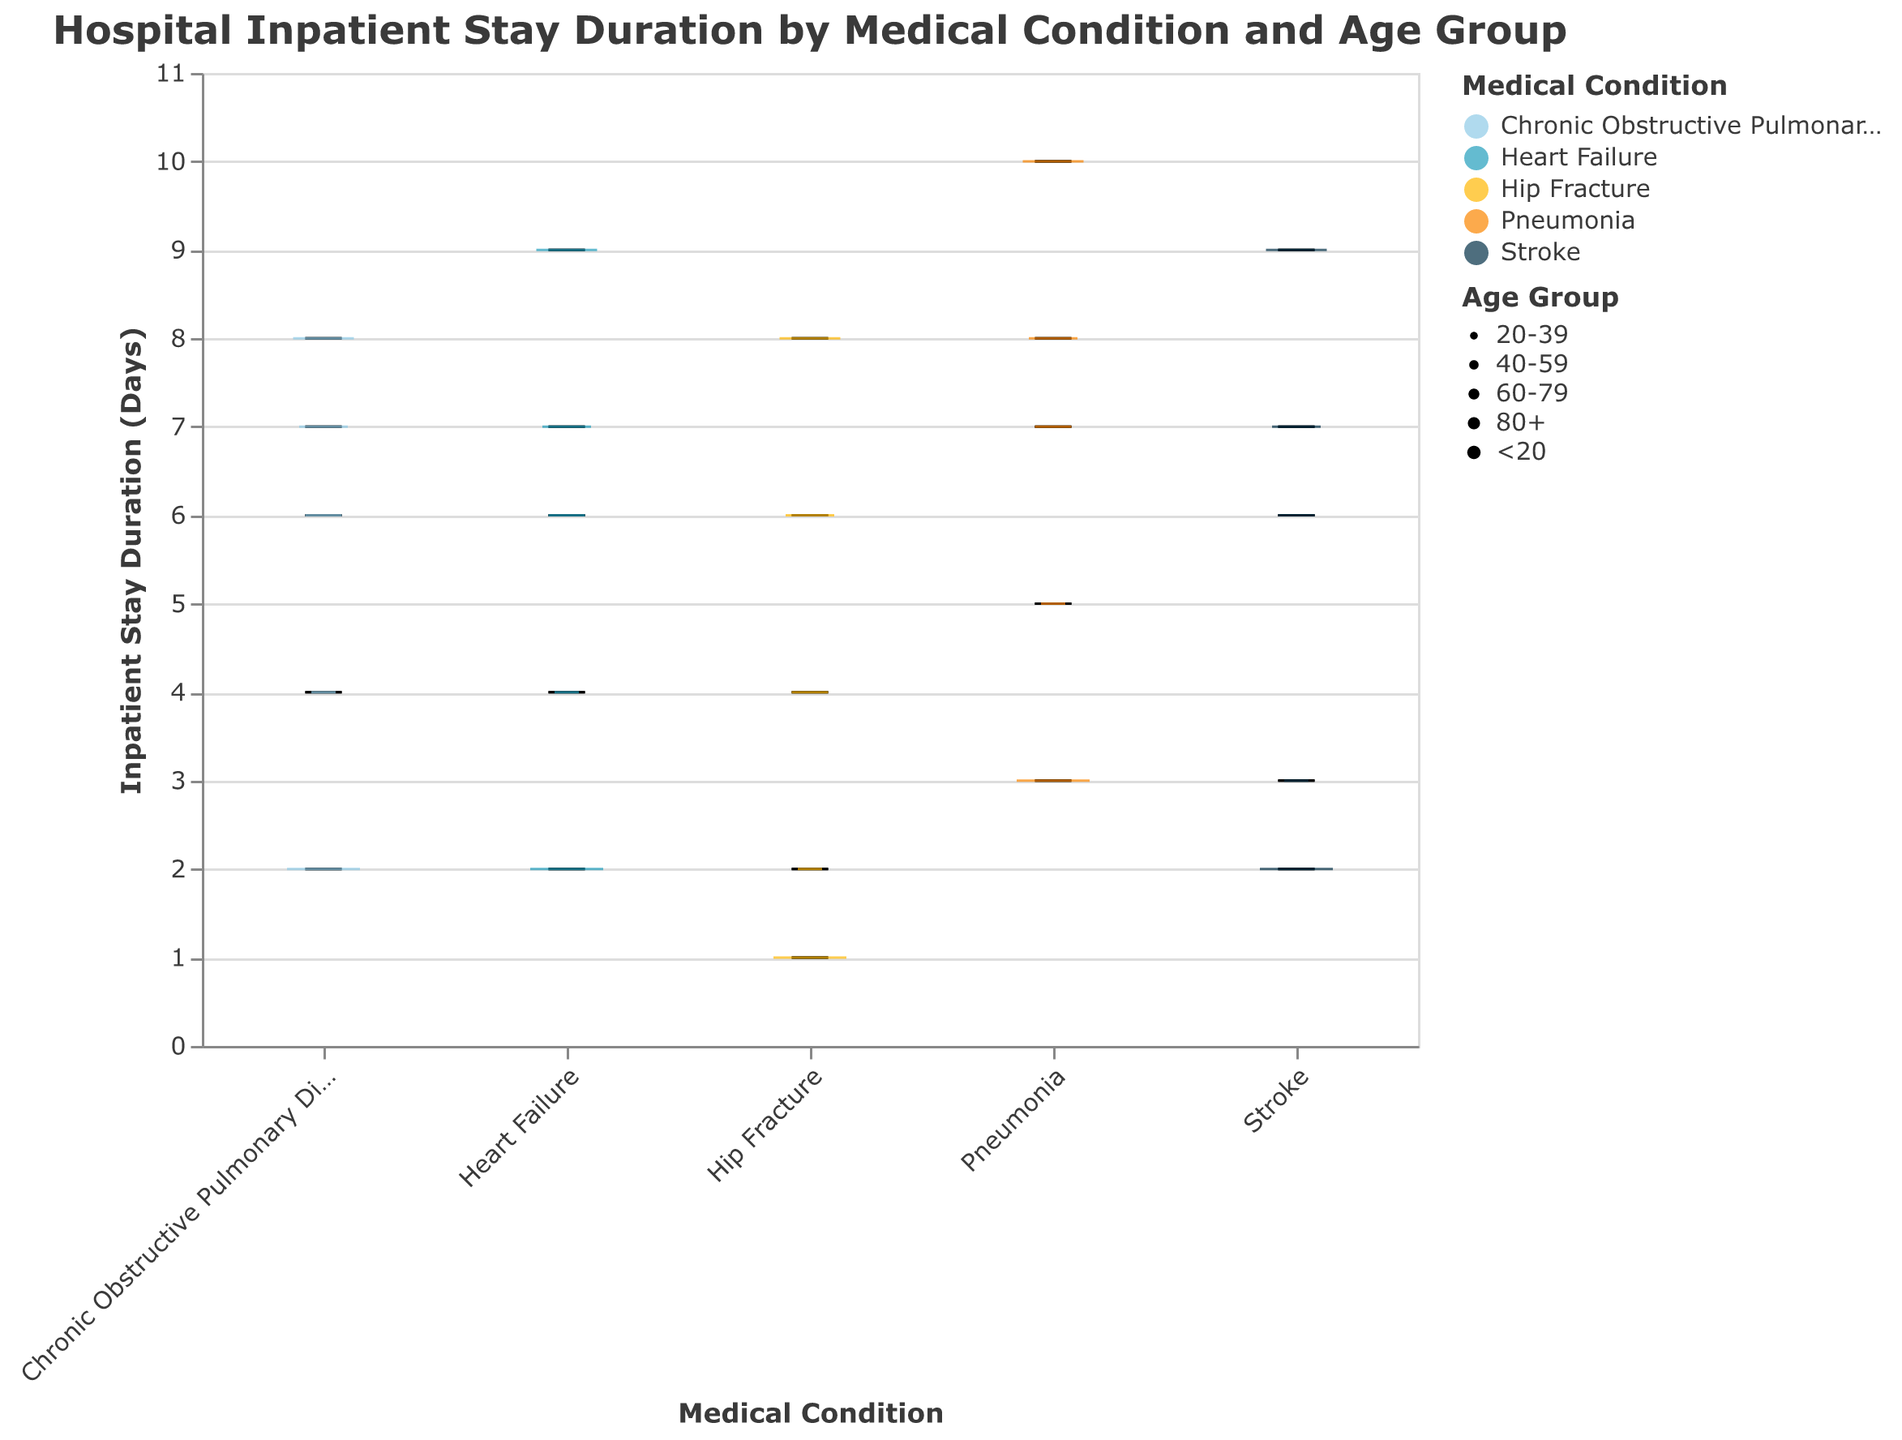What's the title of the figure? The title of the figure is usually prominently displayed at the top. Here, it reads "Hospital Inpatient Stay Duration by Medical Condition and Age Group."
Answer: Hospital Inpatient Stay Duration by Medical Condition and Age Group What is the range of the inpatient stay duration for Heart Failure? The range of inpatient stay duration can be determined by identifying the minimum and maximum points on the y-axis for the Heart Failure box plot. According to the data, it ranges from 2 to 9 days.
Answer: 2 to 9 days Which medical condition has the longest inpatient stay duration for the 80+ age group? By examining the tallest boxplot within the 80+ age group size, we can observe that Pneumonia has the highest inpatient stay duration.
Answer: Pneumonia For which age group does Chronic Obstructive Pulmonary Disease have a median inpatient stay duration of 6 days? By looking at the median line within the boxplot for Chronic Obstructive Pulmonary Disease, we see that the median falls at 6 days for the 40-59 age group.
Answer: 40-59 How does the median inpatient stay duration for Hip Fracture compare between the <20 and 80+ age groups? The median for Hip Fracture in the <20 age group is marked at 1 day, while for the 80+ age group, it is marked at 8 days. Therefore, the median for the 80+ age group is 7 days longer than for the <20 age group.
Answer: 7 days longer What's the difference in inpatient stay duration between Heart Failure and Hip Fracture for the 60-79 age group? The inpatient stay duration for Heart Failure in the 60-79 age group is 7 days, while for Hip Fracture, it is 6 days. The difference is 1 day.
Answer: 1 day Which medical condition shows the least variation in inpatient stay duration across all age groups? Variation can be assessed by observing the width of the boxplot (the interquartile range and overall spread). Stroke shows relatively consistent durations across age groups with narrower box widths compared to others.
Answer: Stroke What are the typical inpatient stay durations for Heart Failure and Pneumonia in the 20-39 age group? For the 20-39 age group, Heart Failure shows an inpatient stay duration of 4 days, and Pneumonia shows a duration of 5 days according to their respective box plots.
Answer: 4 days and 5 days In the 40-59 age group, which medical condition results in the longest median inpatient stay? To find this, we compare the median lines for each condition within the 40-59 age group sizes. Pneumonia has the longest median inpatient stay at 7 days.
Answer: Pneumonia 